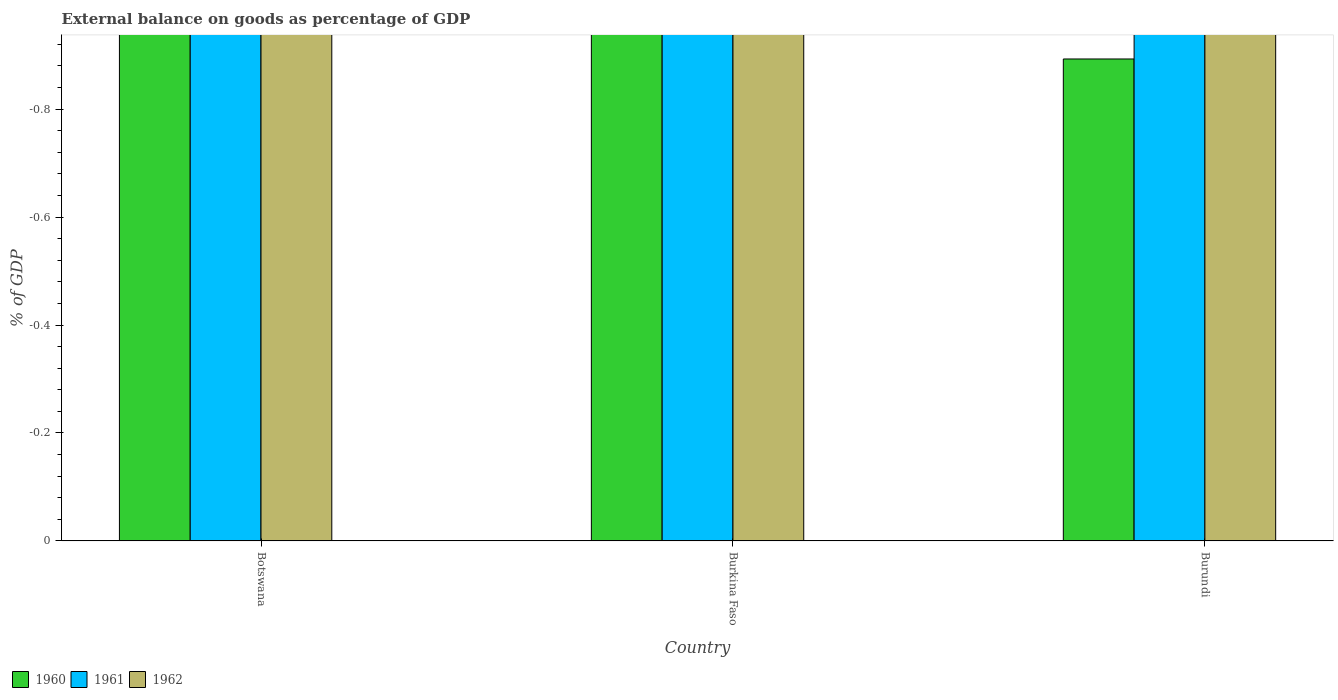How many different coloured bars are there?
Your answer should be compact. 0. How many bars are there on the 3rd tick from the right?
Your answer should be very brief. 0. What is the label of the 3rd group of bars from the left?
Offer a terse response. Burundi. In how many cases, is the number of bars for a given country not equal to the number of legend labels?
Offer a very short reply. 3. Across all countries, what is the minimum external balance on goods as percentage of GDP in 1962?
Give a very brief answer. 0. What is the total external balance on goods as percentage of GDP in 1960 in the graph?
Give a very brief answer. 0. In how many countries, is the external balance on goods as percentage of GDP in 1961 greater than the average external balance on goods as percentage of GDP in 1961 taken over all countries?
Offer a very short reply. 0. Is it the case that in every country, the sum of the external balance on goods as percentage of GDP in 1962 and external balance on goods as percentage of GDP in 1960 is greater than the external balance on goods as percentage of GDP in 1961?
Offer a very short reply. No. How many bars are there?
Offer a very short reply. 0. What is the difference between two consecutive major ticks on the Y-axis?
Your answer should be compact. 0.2. Are the values on the major ticks of Y-axis written in scientific E-notation?
Offer a very short reply. No. Does the graph contain grids?
Your response must be concise. No. Where does the legend appear in the graph?
Provide a short and direct response. Bottom left. How many legend labels are there?
Give a very brief answer. 3. How are the legend labels stacked?
Keep it short and to the point. Horizontal. What is the title of the graph?
Your answer should be very brief. External balance on goods as percentage of GDP. Does "1966" appear as one of the legend labels in the graph?
Your response must be concise. No. What is the label or title of the Y-axis?
Your response must be concise. % of GDP. What is the % of GDP in 1960 in Botswana?
Offer a very short reply. 0. What is the % of GDP of 1961 in Botswana?
Give a very brief answer. 0. What is the % of GDP in 1962 in Botswana?
Your answer should be compact. 0. What is the % of GDP of 1960 in Burkina Faso?
Your answer should be very brief. 0. What is the % of GDP of 1961 in Burkina Faso?
Give a very brief answer. 0. What is the % of GDP of 1962 in Burkina Faso?
Offer a very short reply. 0. What is the % of GDP in 1961 in Burundi?
Ensure brevity in your answer.  0. What is the total % of GDP of 1960 in the graph?
Your answer should be very brief. 0. What is the total % of GDP in 1962 in the graph?
Provide a succinct answer. 0. What is the average % of GDP of 1960 per country?
Make the answer very short. 0. What is the average % of GDP of 1962 per country?
Your answer should be very brief. 0. 